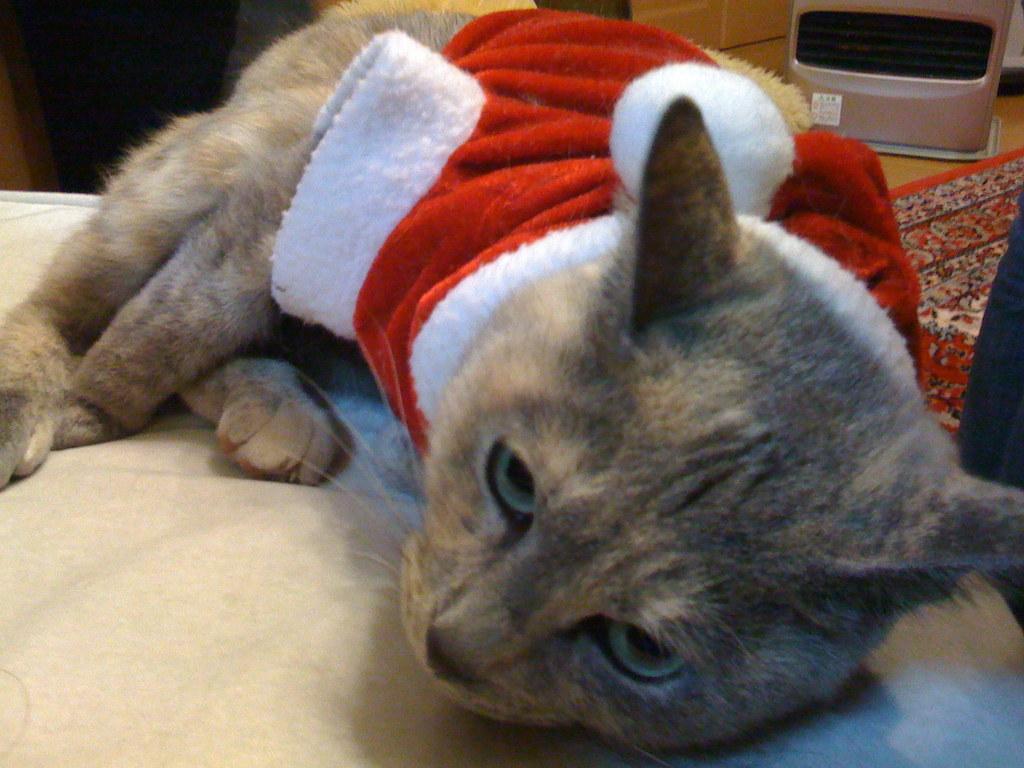Can you describe this image briefly? In this picture we can see a cat on the bed, in the background we can see an object. 